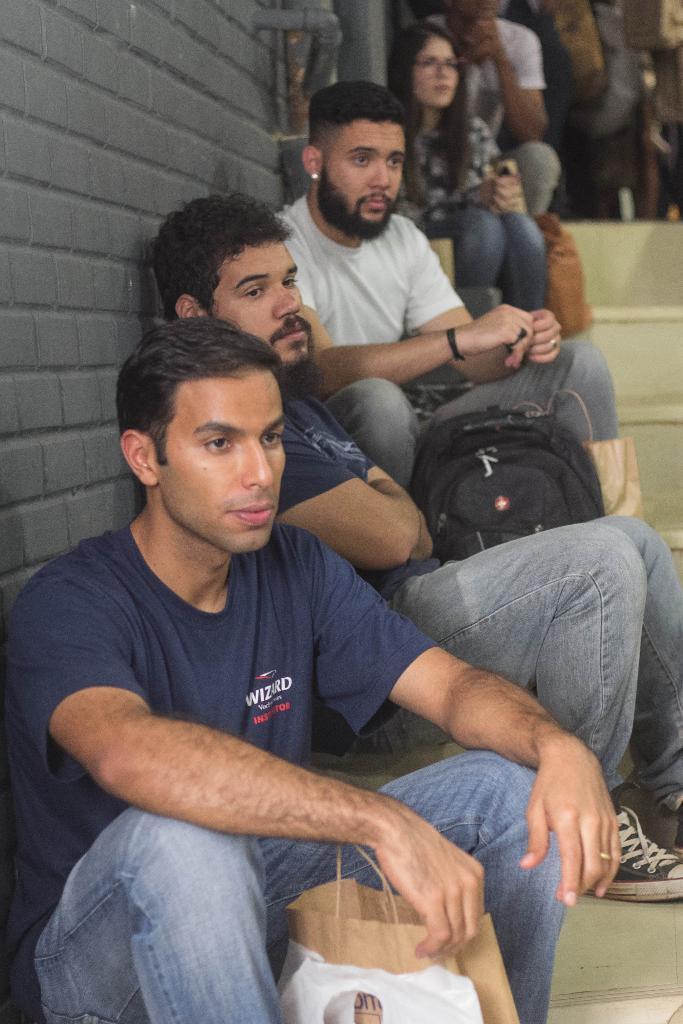Could you give a brief overview of what you see in this image? In this image there are people sitting on the stairs having bags. Left side there is a person sitting on the stairs. Before him there are bags. Left side there is a wall. Right top there are people on the floor. 